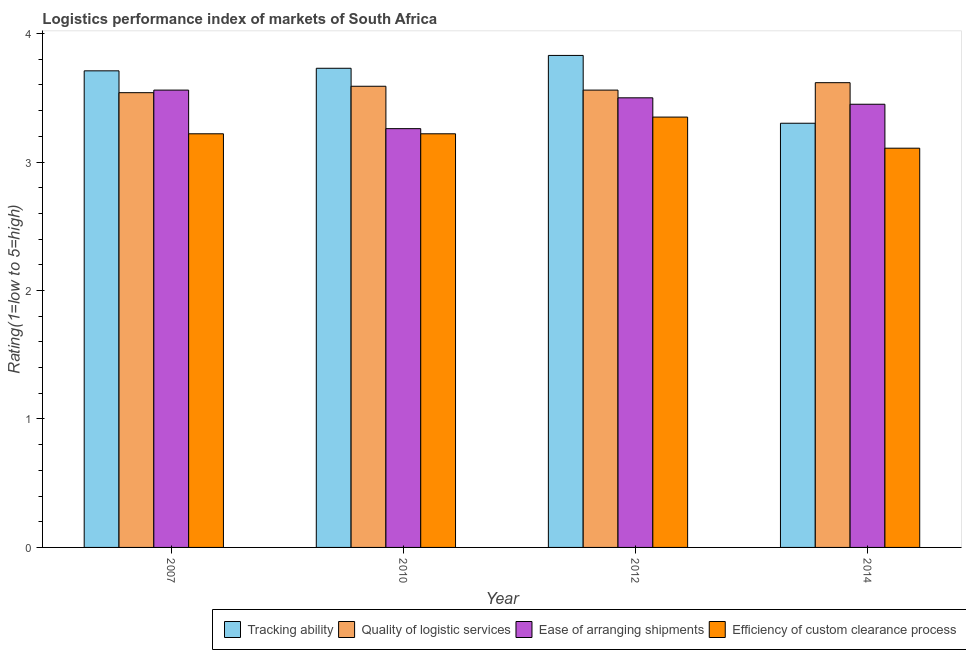How many groups of bars are there?
Keep it short and to the point. 4. Are the number of bars on each tick of the X-axis equal?
Your answer should be very brief. Yes. What is the label of the 4th group of bars from the left?
Offer a very short reply. 2014. In how many cases, is the number of bars for a given year not equal to the number of legend labels?
Keep it short and to the point. 0. What is the lpi rating of quality of logistic services in 2010?
Make the answer very short. 3.59. Across all years, what is the maximum lpi rating of tracking ability?
Offer a very short reply. 3.83. Across all years, what is the minimum lpi rating of quality of logistic services?
Your response must be concise. 3.54. In which year was the lpi rating of quality of logistic services minimum?
Offer a terse response. 2007. What is the total lpi rating of ease of arranging shipments in the graph?
Provide a succinct answer. 13.77. What is the difference between the lpi rating of efficiency of custom clearance process in 2007 and that in 2014?
Provide a succinct answer. 0.11. What is the difference between the lpi rating of efficiency of custom clearance process in 2014 and the lpi rating of tracking ability in 2012?
Keep it short and to the point. -0.24. What is the average lpi rating of ease of arranging shipments per year?
Your answer should be very brief. 3.44. In the year 2007, what is the difference between the lpi rating of quality of logistic services and lpi rating of tracking ability?
Provide a succinct answer. 0. What is the ratio of the lpi rating of efficiency of custom clearance process in 2010 to that in 2012?
Your answer should be compact. 0.96. What is the difference between the highest and the second highest lpi rating of ease of arranging shipments?
Your answer should be compact. 0.06. What is the difference between the highest and the lowest lpi rating of efficiency of custom clearance process?
Provide a short and direct response. 0.24. In how many years, is the lpi rating of tracking ability greater than the average lpi rating of tracking ability taken over all years?
Your answer should be compact. 3. Is it the case that in every year, the sum of the lpi rating of quality of logistic services and lpi rating of tracking ability is greater than the sum of lpi rating of ease of arranging shipments and lpi rating of efficiency of custom clearance process?
Your answer should be very brief. Yes. What does the 1st bar from the left in 2010 represents?
Make the answer very short. Tracking ability. What does the 1st bar from the right in 2007 represents?
Keep it short and to the point. Efficiency of custom clearance process. Are all the bars in the graph horizontal?
Your answer should be compact. No. Are the values on the major ticks of Y-axis written in scientific E-notation?
Your answer should be compact. No. Does the graph contain any zero values?
Your answer should be compact. No. Does the graph contain grids?
Your answer should be very brief. No. Where does the legend appear in the graph?
Give a very brief answer. Bottom right. How many legend labels are there?
Give a very brief answer. 4. What is the title of the graph?
Give a very brief answer. Logistics performance index of markets of South Africa. Does "Self-employed" appear as one of the legend labels in the graph?
Your answer should be very brief. No. What is the label or title of the Y-axis?
Offer a very short reply. Rating(1=low to 5=high). What is the Rating(1=low to 5=high) of Tracking ability in 2007?
Offer a very short reply. 3.71. What is the Rating(1=low to 5=high) in Quality of logistic services in 2007?
Keep it short and to the point. 3.54. What is the Rating(1=low to 5=high) of Ease of arranging shipments in 2007?
Provide a short and direct response. 3.56. What is the Rating(1=low to 5=high) of Efficiency of custom clearance process in 2007?
Your answer should be very brief. 3.22. What is the Rating(1=low to 5=high) of Tracking ability in 2010?
Keep it short and to the point. 3.73. What is the Rating(1=low to 5=high) in Quality of logistic services in 2010?
Ensure brevity in your answer.  3.59. What is the Rating(1=low to 5=high) in Ease of arranging shipments in 2010?
Your answer should be compact. 3.26. What is the Rating(1=low to 5=high) in Efficiency of custom clearance process in 2010?
Keep it short and to the point. 3.22. What is the Rating(1=low to 5=high) in Tracking ability in 2012?
Your answer should be very brief. 3.83. What is the Rating(1=low to 5=high) of Quality of logistic services in 2012?
Offer a terse response. 3.56. What is the Rating(1=low to 5=high) of Efficiency of custom clearance process in 2012?
Make the answer very short. 3.35. What is the Rating(1=low to 5=high) of Tracking ability in 2014?
Ensure brevity in your answer.  3.3. What is the Rating(1=low to 5=high) in Quality of logistic services in 2014?
Provide a short and direct response. 3.62. What is the Rating(1=low to 5=high) of Ease of arranging shipments in 2014?
Your response must be concise. 3.45. What is the Rating(1=low to 5=high) in Efficiency of custom clearance process in 2014?
Your answer should be compact. 3.11. Across all years, what is the maximum Rating(1=low to 5=high) in Tracking ability?
Provide a short and direct response. 3.83. Across all years, what is the maximum Rating(1=low to 5=high) of Quality of logistic services?
Your answer should be compact. 3.62. Across all years, what is the maximum Rating(1=low to 5=high) in Ease of arranging shipments?
Offer a very short reply. 3.56. Across all years, what is the maximum Rating(1=low to 5=high) of Efficiency of custom clearance process?
Offer a terse response. 3.35. Across all years, what is the minimum Rating(1=low to 5=high) in Tracking ability?
Provide a succinct answer. 3.3. Across all years, what is the minimum Rating(1=low to 5=high) of Quality of logistic services?
Your answer should be compact. 3.54. Across all years, what is the minimum Rating(1=low to 5=high) in Ease of arranging shipments?
Your answer should be compact. 3.26. Across all years, what is the minimum Rating(1=low to 5=high) in Efficiency of custom clearance process?
Your response must be concise. 3.11. What is the total Rating(1=low to 5=high) in Tracking ability in the graph?
Keep it short and to the point. 14.57. What is the total Rating(1=low to 5=high) of Quality of logistic services in the graph?
Offer a terse response. 14.31. What is the total Rating(1=low to 5=high) of Ease of arranging shipments in the graph?
Your response must be concise. 13.77. What is the total Rating(1=low to 5=high) in Efficiency of custom clearance process in the graph?
Offer a very short reply. 12.9. What is the difference between the Rating(1=low to 5=high) of Tracking ability in 2007 and that in 2010?
Your response must be concise. -0.02. What is the difference between the Rating(1=low to 5=high) of Quality of logistic services in 2007 and that in 2010?
Your response must be concise. -0.05. What is the difference between the Rating(1=low to 5=high) in Ease of arranging shipments in 2007 and that in 2010?
Your response must be concise. 0.3. What is the difference between the Rating(1=low to 5=high) in Tracking ability in 2007 and that in 2012?
Your response must be concise. -0.12. What is the difference between the Rating(1=low to 5=high) of Quality of logistic services in 2007 and that in 2012?
Your response must be concise. -0.02. What is the difference between the Rating(1=low to 5=high) in Ease of arranging shipments in 2007 and that in 2012?
Ensure brevity in your answer.  0.06. What is the difference between the Rating(1=low to 5=high) of Efficiency of custom clearance process in 2007 and that in 2012?
Your answer should be very brief. -0.13. What is the difference between the Rating(1=low to 5=high) of Tracking ability in 2007 and that in 2014?
Your response must be concise. 0.41. What is the difference between the Rating(1=low to 5=high) of Quality of logistic services in 2007 and that in 2014?
Your answer should be very brief. -0.08. What is the difference between the Rating(1=low to 5=high) of Ease of arranging shipments in 2007 and that in 2014?
Keep it short and to the point. 0.11. What is the difference between the Rating(1=low to 5=high) of Efficiency of custom clearance process in 2007 and that in 2014?
Provide a short and direct response. 0.11. What is the difference between the Rating(1=low to 5=high) in Ease of arranging shipments in 2010 and that in 2012?
Your answer should be compact. -0.24. What is the difference between the Rating(1=low to 5=high) in Efficiency of custom clearance process in 2010 and that in 2012?
Your response must be concise. -0.13. What is the difference between the Rating(1=low to 5=high) in Tracking ability in 2010 and that in 2014?
Give a very brief answer. 0.43. What is the difference between the Rating(1=low to 5=high) in Quality of logistic services in 2010 and that in 2014?
Provide a succinct answer. -0.03. What is the difference between the Rating(1=low to 5=high) in Ease of arranging shipments in 2010 and that in 2014?
Your answer should be compact. -0.19. What is the difference between the Rating(1=low to 5=high) of Efficiency of custom clearance process in 2010 and that in 2014?
Offer a terse response. 0.11. What is the difference between the Rating(1=low to 5=high) of Tracking ability in 2012 and that in 2014?
Ensure brevity in your answer.  0.53. What is the difference between the Rating(1=low to 5=high) of Quality of logistic services in 2012 and that in 2014?
Offer a terse response. -0.06. What is the difference between the Rating(1=low to 5=high) in Efficiency of custom clearance process in 2012 and that in 2014?
Make the answer very short. 0.24. What is the difference between the Rating(1=low to 5=high) of Tracking ability in 2007 and the Rating(1=low to 5=high) of Quality of logistic services in 2010?
Offer a very short reply. 0.12. What is the difference between the Rating(1=low to 5=high) in Tracking ability in 2007 and the Rating(1=low to 5=high) in Ease of arranging shipments in 2010?
Your response must be concise. 0.45. What is the difference between the Rating(1=low to 5=high) in Tracking ability in 2007 and the Rating(1=low to 5=high) in Efficiency of custom clearance process in 2010?
Your answer should be very brief. 0.49. What is the difference between the Rating(1=low to 5=high) of Quality of logistic services in 2007 and the Rating(1=low to 5=high) of Ease of arranging shipments in 2010?
Offer a terse response. 0.28. What is the difference between the Rating(1=low to 5=high) of Quality of logistic services in 2007 and the Rating(1=low to 5=high) of Efficiency of custom clearance process in 2010?
Your answer should be compact. 0.32. What is the difference between the Rating(1=low to 5=high) in Ease of arranging shipments in 2007 and the Rating(1=low to 5=high) in Efficiency of custom clearance process in 2010?
Offer a very short reply. 0.34. What is the difference between the Rating(1=low to 5=high) of Tracking ability in 2007 and the Rating(1=low to 5=high) of Quality of logistic services in 2012?
Ensure brevity in your answer.  0.15. What is the difference between the Rating(1=low to 5=high) in Tracking ability in 2007 and the Rating(1=low to 5=high) in Ease of arranging shipments in 2012?
Offer a very short reply. 0.21. What is the difference between the Rating(1=low to 5=high) of Tracking ability in 2007 and the Rating(1=low to 5=high) of Efficiency of custom clearance process in 2012?
Give a very brief answer. 0.36. What is the difference between the Rating(1=low to 5=high) in Quality of logistic services in 2007 and the Rating(1=low to 5=high) in Ease of arranging shipments in 2012?
Keep it short and to the point. 0.04. What is the difference between the Rating(1=low to 5=high) of Quality of logistic services in 2007 and the Rating(1=low to 5=high) of Efficiency of custom clearance process in 2012?
Offer a very short reply. 0.19. What is the difference between the Rating(1=low to 5=high) in Ease of arranging shipments in 2007 and the Rating(1=low to 5=high) in Efficiency of custom clearance process in 2012?
Your answer should be compact. 0.21. What is the difference between the Rating(1=low to 5=high) in Tracking ability in 2007 and the Rating(1=low to 5=high) in Quality of logistic services in 2014?
Your answer should be very brief. 0.09. What is the difference between the Rating(1=low to 5=high) of Tracking ability in 2007 and the Rating(1=low to 5=high) of Ease of arranging shipments in 2014?
Your response must be concise. 0.26. What is the difference between the Rating(1=low to 5=high) of Tracking ability in 2007 and the Rating(1=low to 5=high) of Efficiency of custom clearance process in 2014?
Make the answer very short. 0.6. What is the difference between the Rating(1=low to 5=high) in Quality of logistic services in 2007 and the Rating(1=low to 5=high) in Ease of arranging shipments in 2014?
Provide a succinct answer. 0.09. What is the difference between the Rating(1=low to 5=high) in Quality of logistic services in 2007 and the Rating(1=low to 5=high) in Efficiency of custom clearance process in 2014?
Your answer should be compact. 0.43. What is the difference between the Rating(1=low to 5=high) of Ease of arranging shipments in 2007 and the Rating(1=low to 5=high) of Efficiency of custom clearance process in 2014?
Provide a short and direct response. 0.45. What is the difference between the Rating(1=low to 5=high) in Tracking ability in 2010 and the Rating(1=low to 5=high) in Quality of logistic services in 2012?
Provide a short and direct response. 0.17. What is the difference between the Rating(1=low to 5=high) of Tracking ability in 2010 and the Rating(1=low to 5=high) of Ease of arranging shipments in 2012?
Make the answer very short. 0.23. What is the difference between the Rating(1=low to 5=high) of Tracking ability in 2010 and the Rating(1=low to 5=high) of Efficiency of custom clearance process in 2012?
Provide a succinct answer. 0.38. What is the difference between the Rating(1=low to 5=high) of Quality of logistic services in 2010 and the Rating(1=low to 5=high) of Ease of arranging shipments in 2012?
Offer a very short reply. 0.09. What is the difference between the Rating(1=low to 5=high) of Quality of logistic services in 2010 and the Rating(1=low to 5=high) of Efficiency of custom clearance process in 2012?
Provide a short and direct response. 0.24. What is the difference between the Rating(1=low to 5=high) in Ease of arranging shipments in 2010 and the Rating(1=low to 5=high) in Efficiency of custom clearance process in 2012?
Give a very brief answer. -0.09. What is the difference between the Rating(1=low to 5=high) in Tracking ability in 2010 and the Rating(1=low to 5=high) in Quality of logistic services in 2014?
Offer a very short reply. 0.11. What is the difference between the Rating(1=low to 5=high) in Tracking ability in 2010 and the Rating(1=low to 5=high) in Ease of arranging shipments in 2014?
Make the answer very short. 0.28. What is the difference between the Rating(1=low to 5=high) of Tracking ability in 2010 and the Rating(1=low to 5=high) of Efficiency of custom clearance process in 2014?
Your answer should be compact. 0.62. What is the difference between the Rating(1=low to 5=high) in Quality of logistic services in 2010 and the Rating(1=low to 5=high) in Ease of arranging shipments in 2014?
Offer a very short reply. 0.14. What is the difference between the Rating(1=low to 5=high) of Quality of logistic services in 2010 and the Rating(1=low to 5=high) of Efficiency of custom clearance process in 2014?
Your answer should be compact. 0.48. What is the difference between the Rating(1=low to 5=high) of Ease of arranging shipments in 2010 and the Rating(1=low to 5=high) of Efficiency of custom clearance process in 2014?
Your answer should be very brief. 0.15. What is the difference between the Rating(1=low to 5=high) in Tracking ability in 2012 and the Rating(1=low to 5=high) in Quality of logistic services in 2014?
Offer a very short reply. 0.21. What is the difference between the Rating(1=low to 5=high) in Tracking ability in 2012 and the Rating(1=low to 5=high) in Ease of arranging shipments in 2014?
Offer a terse response. 0.38. What is the difference between the Rating(1=low to 5=high) in Tracking ability in 2012 and the Rating(1=low to 5=high) in Efficiency of custom clearance process in 2014?
Your answer should be compact. 0.72. What is the difference between the Rating(1=low to 5=high) in Quality of logistic services in 2012 and the Rating(1=low to 5=high) in Ease of arranging shipments in 2014?
Offer a terse response. 0.11. What is the difference between the Rating(1=low to 5=high) of Quality of logistic services in 2012 and the Rating(1=low to 5=high) of Efficiency of custom clearance process in 2014?
Ensure brevity in your answer.  0.45. What is the difference between the Rating(1=low to 5=high) of Ease of arranging shipments in 2012 and the Rating(1=low to 5=high) of Efficiency of custom clearance process in 2014?
Make the answer very short. 0.39. What is the average Rating(1=low to 5=high) of Tracking ability per year?
Your answer should be compact. 3.64. What is the average Rating(1=low to 5=high) in Quality of logistic services per year?
Your answer should be compact. 3.58. What is the average Rating(1=low to 5=high) in Ease of arranging shipments per year?
Your answer should be very brief. 3.44. What is the average Rating(1=low to 5=high) of Efficiency of custom clearance process per year?
Ensure brevity in your answer.  3.22. In the year 2007, what is the difference between the Rating(1=low to 5=high) in Tracking ability and Rating(1=low to 5=high) in Quality of logistic services?
Keep it short and to the point. 0.17. In the year 2007, what is the difference between the Rating(1=low to 5=high) in Tracking ability and Rating(1=low to 5=high) in Efficiency of custom clearance process?
Ensure brevity in your answer.  0.49. In the year 2007, what is the difference between the Rating(1=low to 5=high) in Quality of logistic services and Rating(1=low to 5=high) in Ease of arranging shipments?
Ensure brevity in your answer.  -0.02. In the year 2007, what is the difference between the Rating(1=low to 5=high) of Quality of logistic services and Rating(1=low to 5=high) of Efficiency of custom clearance process?
Ensure brevity in your answer.  0.32. In the year 2007, what is the difference between the Rating(1=low to 5=high) in Ease of arranging shipments and Rating(1=low to 5=high) in Efficiency of custom clearance process?
Offer a terse response. 0.34. In the year 2010, what is the difference between the Rating(1=low to 5=high) of Tracking ability and Rating(1=low to 5=high) of Quality of logistic services?
Offer a terse response. 0.14. In the year 2010, what is the difference between the Rating(1=low to 5=high) in Tracking ability and Rating(1=low to 5=high) in Ease of arranging shipments?
Your answer should be compact. 0.47. In the year 2010, what is the difference between the Rating(1=low to 5=high) in Tracking ability and Rating(1=low to 5=high) in Efficiency of custom clearance process?
Offer a terse response. 0.51. In the year 2010, what is the difference between the Rating(1=low to 5=high) of Quality of logistic services and Rating(1=low to 5=high) of Ease of arranging shipments?
Your response must be concise. 0.33. In the year 2010, what is the difference between the Rating(1=low to 5=high) of Quality of logistic services and Rating(1=low to 5=high) of Efficiency of custom clearance process?
Ensure brevity in your answer.  0.37. In the year 2012, what is the difference between the Rating(1=low to 5=high) in Tracking ability and Rating(1=low to 5=high) in Quality of logistic services?
Offer a very short reply. 0.27. In the year 2012, what is the difference between the Rating(1=low to 5=high) in Tracking ability and Rating(1=low to 5=high) in Ease of arranging shipments?
Provide a succinct answer. 0.33. In the year 2012, what is the difference between the Rating(1=low to 5=high) in Tracking ability and Rating(1=low to 5=high) in Efficiency of custom clearance process?
Make the answer very short. 0.48. In the year 2012, what is the difference between the Rating(1=low to 5=high) in Quality of logistic services and Rating(1=low to 5=high) in Efficiency of custom clearance process?
Ensure brevity in your answer.  0.21. In the year 2012, what is the difference between the Rating(1=low to 5=high) in Ease of arranging shipments and Rating(1=low to 5=high) in Efficiency of custom clearance process?
Offer a terse response. 0.15. In the year 2014, what is the difference between the Rating(1=low to 5=high) in Tracking ability and Rating(1=low to 5=high) in Quality of logistic services?
Your response must be concise. -0.32. In the year 2014, what is the difference between the Rating(1=low to 5=high) of Tracking ability and Rating(1=low to 5=high) of Ease of arranging shipments?
Offer a very short reply. -0.15. In the year 2014, what is the difference between the Rating(1=low to 5=high) in Tracking ability and Rating(1=low to 5=high) in Efficiency of custom clearance process?
Your response must be concise. 0.19. In the year 2014, what is the difference between the Rating(1=low to 5=high) of Quality of logistic services and Rating(1=low to 5=high) of Ease of arranging shipments?
Keep it short and to the point. 0.17. In the year 2014, what is the difference between the Rating(1=low to 5=high) in Quality of logistic services and Rating(1=low to 5=high) in Efficiency of custom clearance process?
Offer a terse response. 0.51. In the year 2014, what is the difference between the Rating(1=low to 5=high) in Ease of arranging shipments and Rating(1=low to 5=high) in Efficiency of custom clearance process?
Offer a terse response. 0.34. What is the ratio of the Rating(1=low to 5=high) of Quality of logistic services in 2007 to that in 2010?
Your response must be concise. 0.99. What is the ratio of the Rating(1=low to 5=high) in Ease of arranging shipments in 2007 to that in 2010?
Ensure brevity in your answer.  1.09. What is the ratio of the Rating(1=low to 5=high) in Efficiency of custom clearance process in 2007 to that in 2010?
Provide a short and direct response. 1. What is the ratio of the Rating(1=low to 5=high) of Tracking ability in 2007 to that in 2012?
Offer a terse response. 0.97. What is the ratio of the Rating(1=low to 5=high) of Ease of arranging shipments in 2007 to that in 2012?
Make the answer very short. 1.02. What is the ratio of the Rating(1=low to 5=high) in Efficiency of custom clearance process in 2007 to that in 2012?
Make the answer very short. 0.96. What is the ratio of the Rating(1=low to 5=high) in Tracking ability in 2007 to that in 2014?
Ensure brevity in your answer.  1.12. What is the ratio of the Rating(1=low to 5=high) of Quality of logistic services in 2007 to that in 2014?
Your response must be concise. 0.98. What is the ratio of the Rating(1=low to 5=high) in Ease of arranging shipments in 2007 to that in 2014?
Keep it short and to the point. 1.03. What is the ratio of the Rating(1=low to 5=high) in Efficiency of custom clearance process in 2007 to that in 2014?
Your answer should be very brief. 1.04. What is the ratio of the Rating(1=low to 5=high) of Tracking ability in 2010 to that in 2012?
Provide a succinct answer. 0.97. What is the ratio of the Rating(1=low to 5=high) of Quality of logistic services in 2010 to that in 2012?
Make the answer very short. 1.01. What is the ratio of the Rating(1=low to 5=high) in Ease of arranging shipments in 2010 to that in 2012?
Provide a short and direct response. 0.93. What is the ratio of the Rating(1=low to 5=high) of Efficiency of custom clearance process in 2010 to that in 2012?
Ensure brevity in your answer.  0.96. What is the ratio of the Rating(1=low to 5=high) of Tracking ability in 2010 to that in 2014?
Give a very brief answer. 1.13. What is the ratio of the Rating(1=low to 5=high) in Ease of arranging shipments in 2010 to that in 2014?
Provide a succinct answer. 0.94. What is the ratio of the Rating(1=low to 5=high) of Efficiency of custom clearance process in 2010 to that in 2014?
Make the answer very short. 1.04. What is the ratio of the Rating(1=low to 5=high) in Tracking ability in 2012 to that in 2014?
Your response must be concise. 1.16. What is the ratio of the Rating(1=low to 5=high) of Ease of arranging shipments in 2012 to that in 2014?
Ensure brevity in your answer.  1.01. What is the ratio of the Rating(1=low to 5=high) in Efficiency of custom clearance process in 2012 to that in 2014?
Make the answer very short. 1.08. What is the difference between the highest and the second highest Rating(1=low to 5=high) in Quality of logistic services?
Keep it short and to the point. 0.03. What is the difference between the highest and the second highest Rating(1=low to 5=high) of Ease of arranging shipments?
Provide a succinct answer. 0.06. What is the difference between the highest and the second highest Rating(1=low to 5=high) of Efficiency of custom clearance process?
Your answer should be very brief. 0.13. What is the difference between the highest and the lowest Rating(1=low to 5=high) in Tracking ability?
Provide a short and direct response. 0.53. What is the difference between the highest and the lowest Rating(1=low to 5=high) in Quality of logistic services?
Make the answer very short. 0.08. What is the difference between the highest and the lowest Rating(1=low to 5=high) of Ease of arranging shipments?
Make the answer very short. 0.3. What is the difference between the highest and the lowest Rating(1=low to 5=high) in Efficiency of custom clearance process?
Give a very brief answer. 0.24. 